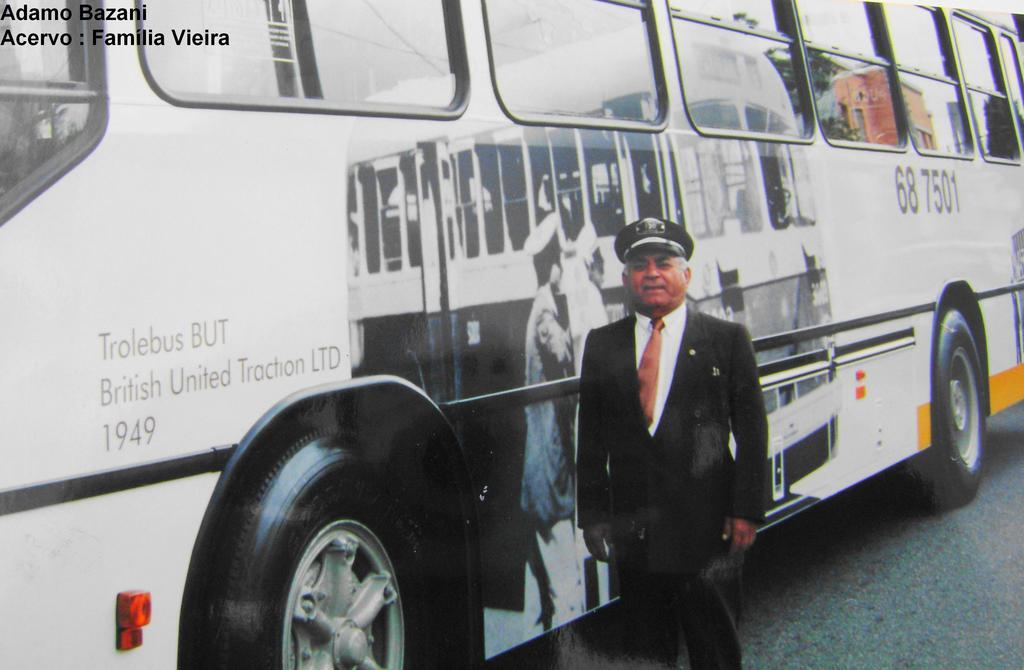<image>
Give a short and clear explanation of the subsequent image. A man stands outside of the Trolebus BUT 